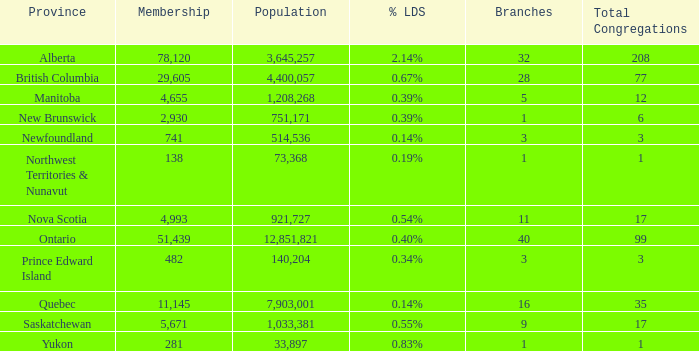What is the combined population when the membership amounts to 51,439 for under 40 branches? None. 